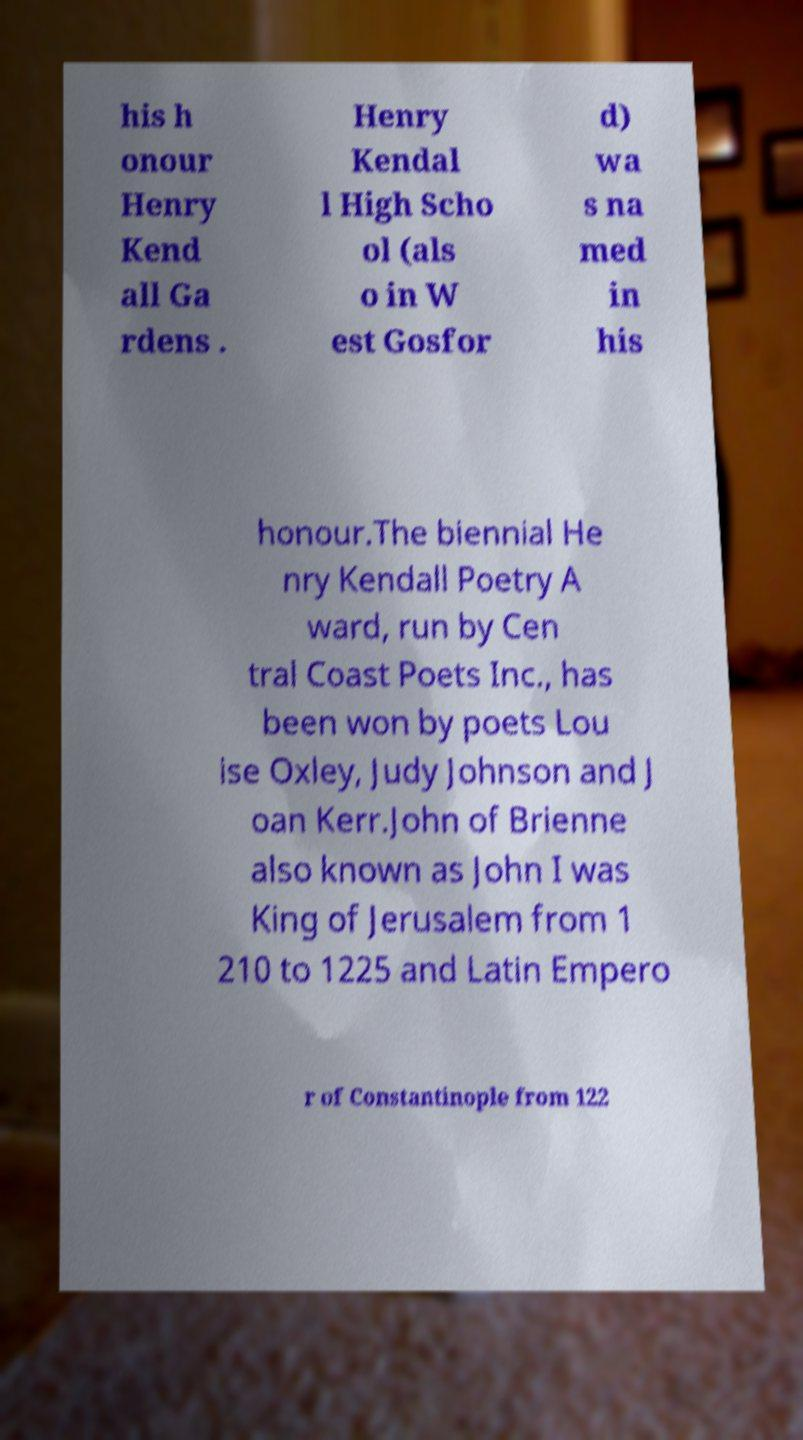I need the written content from this picture converted into text. Can you do that? his h onour Henry Kend all Ga rdens . Henry Kendal l High Scho ol (als o in W est Gosfor d) wa s na med in his honour.The biennial He nry Kendall Poetry A ward, run by Cen tral Coast Poets Inc., has been won by poets Lou ise Oxley, Judy Johnson and J oan Kerr.John of Brienne also known as John I was King of Jerusalem from 1 210 to 1225 and Latin Empero r of Constantinople from 122 